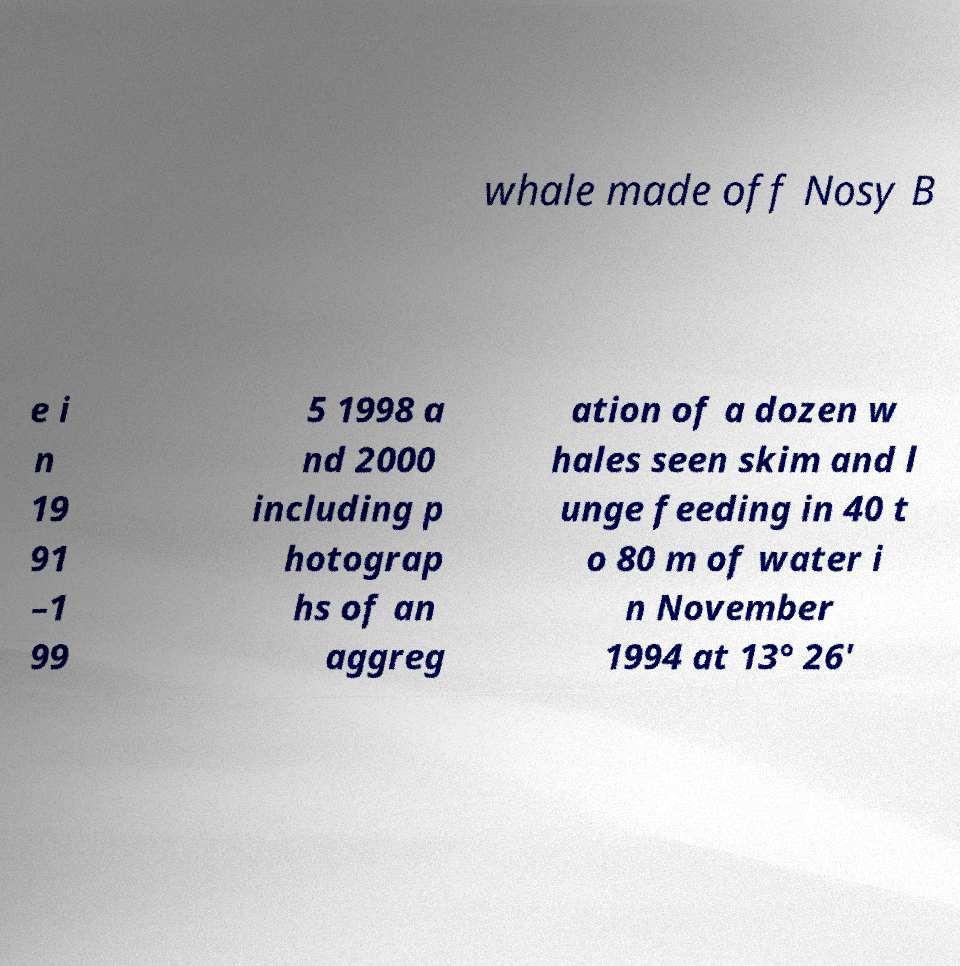Please identify and transcribe the text found in this image. whale made off Nosy B e i n 19 91 –1 99 5 1998 a nd 2000 including p hotograp hs of an aggreg ation of a dozen w hales seen skim and l unge feeding in 40 t o 80 m of water i n November 1994 at 13° 26' 